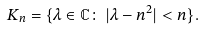Convert formula to latex. <formula><loc_0><loc_0><loc_500><loc_500>K _ { n } = \{ \lambda \in \mathbb { C } \colon \, | \lambda - n ^ { 2 } | < n \} .</formula> 